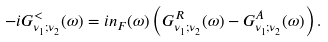Convert formula to latex. <formula><loc_0><loc_0><loc_500><loc_500>- i G ^ { < } _ { \nu _ { 1 } ; \nu _ { 2 } } ( \omega ) = i n _ { F } ( \omega ) \left ( G ^ { R } _ { \nu _ { 1 } ; \nu _ { 2 } } ( \omega ) - G ^ { A } _ { \nu _ { 1 } ; \nu _ { 2 } } ( \omega ) \right ) .</formula> 